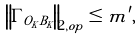Convert formula to latex. <formula><loc_0><loc_0><loc_500><loc_500>\left \| \Gamma _ { O _ { K } B _ { K } } \right \| _ { 2 , o p } \leq m ^ { \prime } ,</formula> 